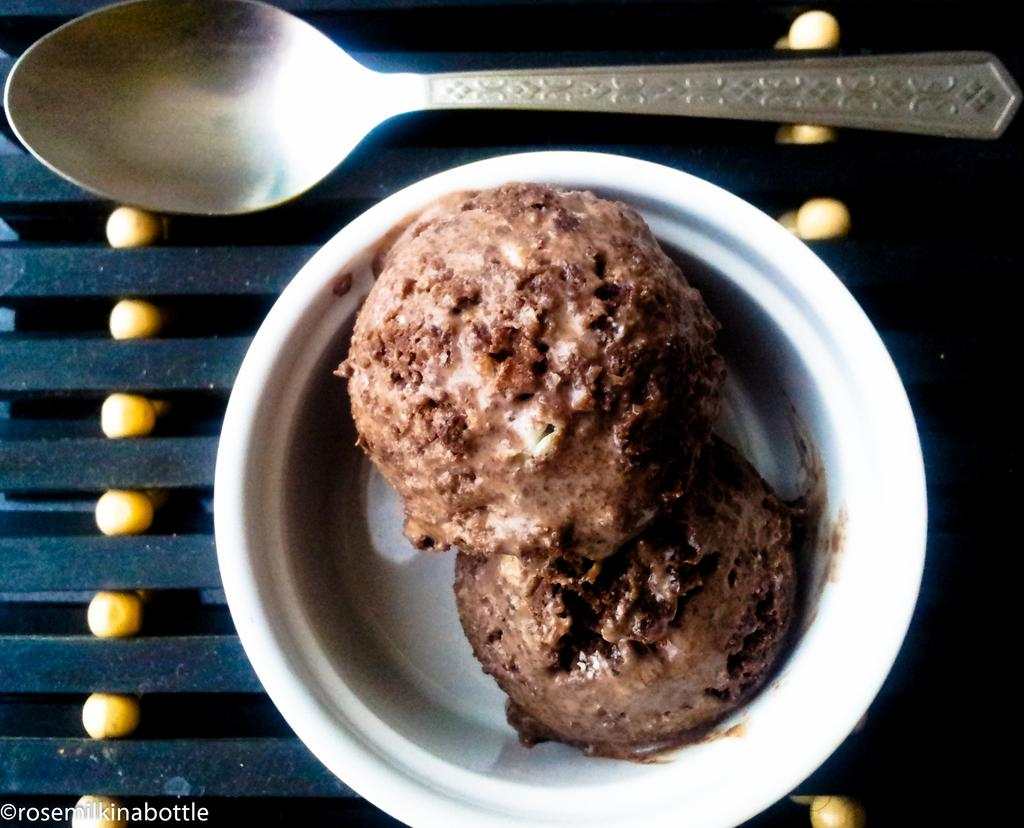What color is the bowl in the image? The bowl in the image is white. What is inside the bowl? The bowl contains two scoops of chocolate ice cream. What utensil is placed beside the bowl? There is a spoon beside the bowl. Are there any masks visible in the image? No, there are no masks present in the image. How many hands are holding the bowl in the image? There are no hands visible in the image, as the bowl is not being held by anyone. 